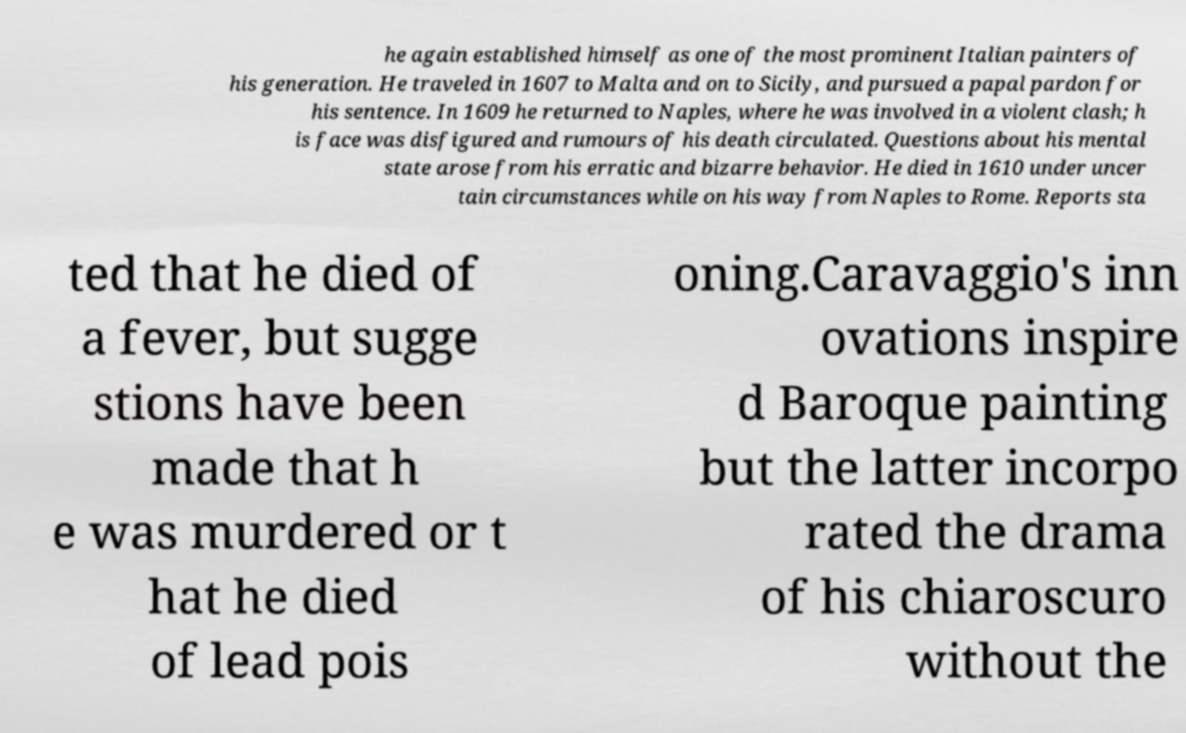Can you read and provide the text displayed in the image?This photo seems to have some interesting text. Can you extract and type it out for me? he again established himself as one of the most prominent Italian painters of his generation. He traveled in 1607 to Malta and on to Sicily, and pursued a papal pardon for his sentence. In 1609 he returned to Naples, where he was involved in a violent clash; h is face was disfigured and rumours of his death circulated. Questions about his mental state arose from his erratic and bizarre behavior. He died in 1610 under uncer tain circumstances while on his way from Naples to Rome. Reports sta ted that he died of a fever, but sugge stions have been made that h e was murdered or t hat he died of lead pois oning.Caravaggio's inn ovations inspire d Baroque painting but the latter incorpo rated the drama of his chiaroscuro without the 